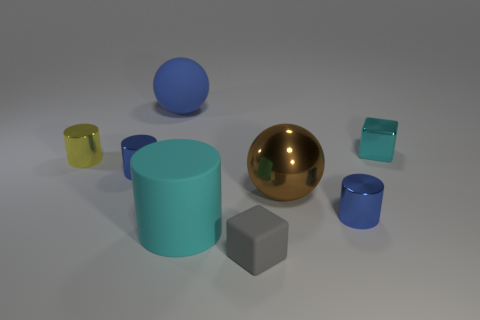Subtract all gray cubes. How many blue cylinders are left? 2 Subtract 1 cylinders. How many cylinders are left? 3 Subtract all small yellow shiny cylinders. How many cylinders are left? 3 Subtract all yellow cylinders. How many cylinders are left? 3 Add 1 big green metal balls. How many objects exist? 9 Subtract all gray cylinders. Subtract all cyan spheres. How many cylinders are left? 4 Subtract all balls. How many objects are left? 6 Add 4 tiny gray matte cubes. How many tiny gray matte cubes are left? 5 Add 6 cyan metallic cubes. How many cyan metallic cubes exist? 7 Subtract 1 yellow cylinders. How many objects are left? 7 